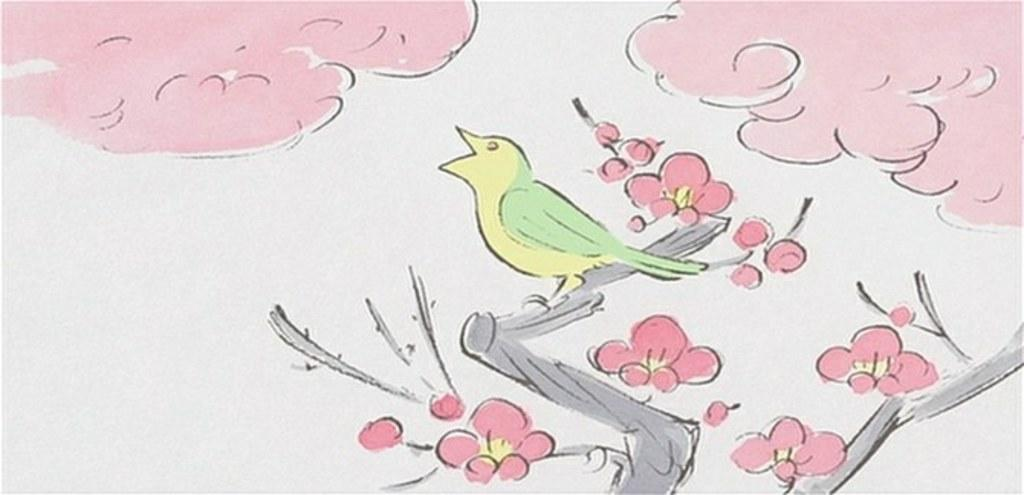What is depicted in the sky of the painting? The painting contains clouds in the sky. What type of animal can be seen in the painting? There is a bird in the painting. Where is the bird located in the painting? The bird is standing on the branch of a tree. What additional feature can be observed on the tree in the painting? The tree has flowers in the painting. Can you hear the thunder in the painting? There is no thunder present in the painting; it is a visual representation and does not include sound. 